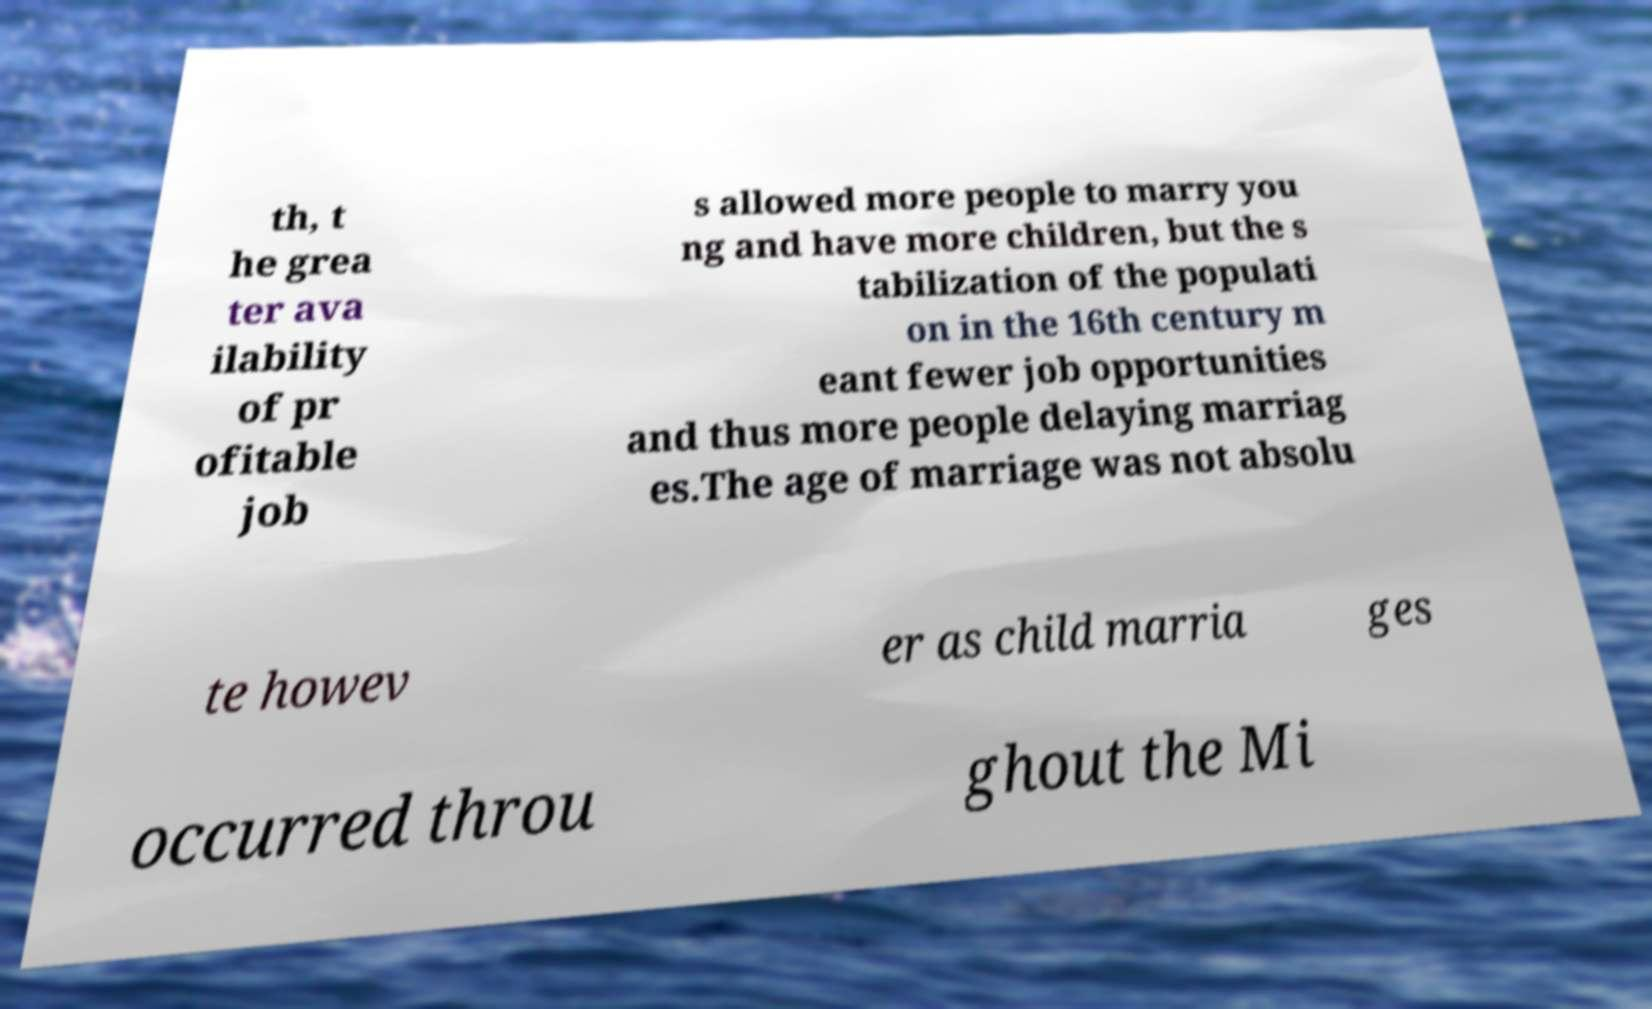Could you extract and type out the text from this image? th, t he grea ter ava ilability of pr ofitable job s allowed more people to marry you ng and have more children, but the s tabilization of the populati on in the 16th century m eant fewer job opportunities and thus more people delaying marriag es.The age of marriage was not absolu te howev er as child marria ges occurred throu ghout the Mi 